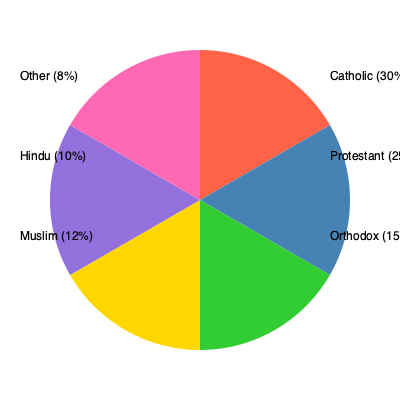As a spiritual guide, you're discussing religious diversity with a group of young believers. The pie chart shows the distribution of major religious denominations in a particular region. What fraction of the population identifies as either Catholic or Orthodox? To solve this question, we need to follow these steps:

1. Identify the percentages for Catholic and Orthodox believers from the pie chart:
   - Catholic: 30%
   - Orthodox: 15%

2. Convert these percentages to fractions:
   - Catholic: 30% = $\frac{30}{100}$
   - Orthodox: 15% = $\frac{15}{100}$

3. Add these fractions together:
   $\frac{30}{100} + \frac{15}{100} = \frac{45}{100}$

4. Simplify the fraction:
   $\frac{45}{100}$ can be reduced by dividing both numerator and denominator by their greatest common divisor (5):
   $\frac{45 \div 5}{100 \div 5} = \frac{9}{20}$

Therefore, the fraction of the population that identifies as either Catholic or Orthodox is $\frac{9}{20}$.
Answer: $\frac{9}{20}$ 